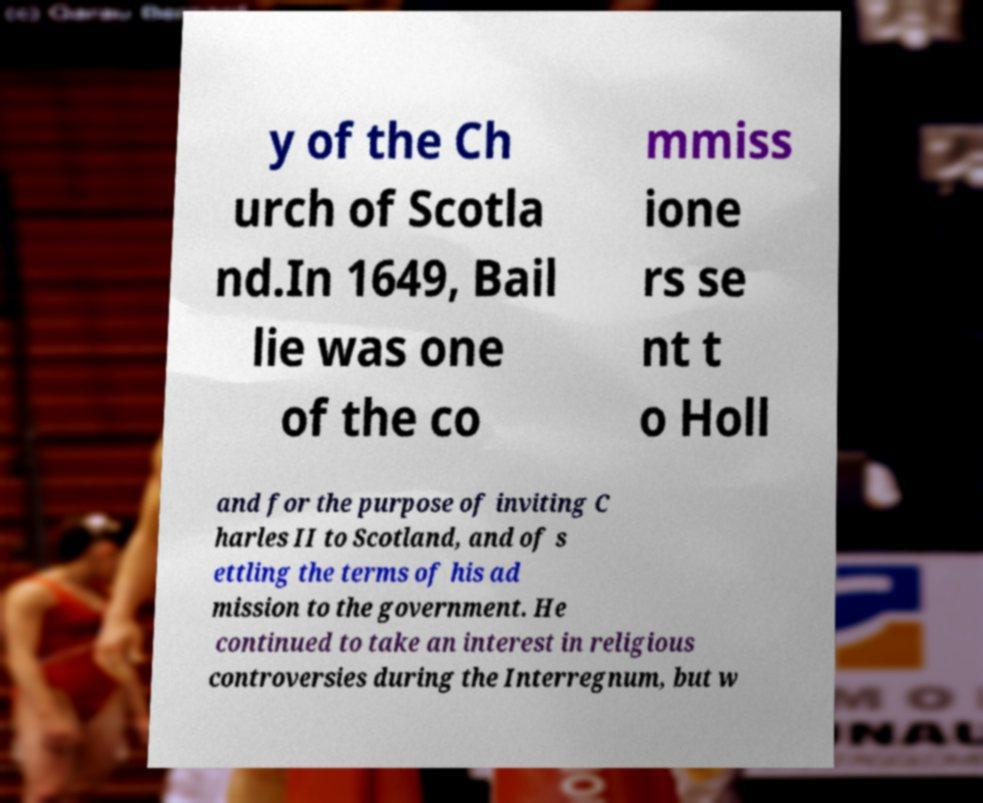Could you extract and type out the text from this image? y of the Ch urch of Scotla nd.In 1649, Bail lie was one of the co mmiss ione rs se nt t o Holl and for the purpose of inviting C harles II to Scotland, and of s ettling the terms of his ad mission to the government. He continued to take an interest in religious controversies during the Interregnum, but w 